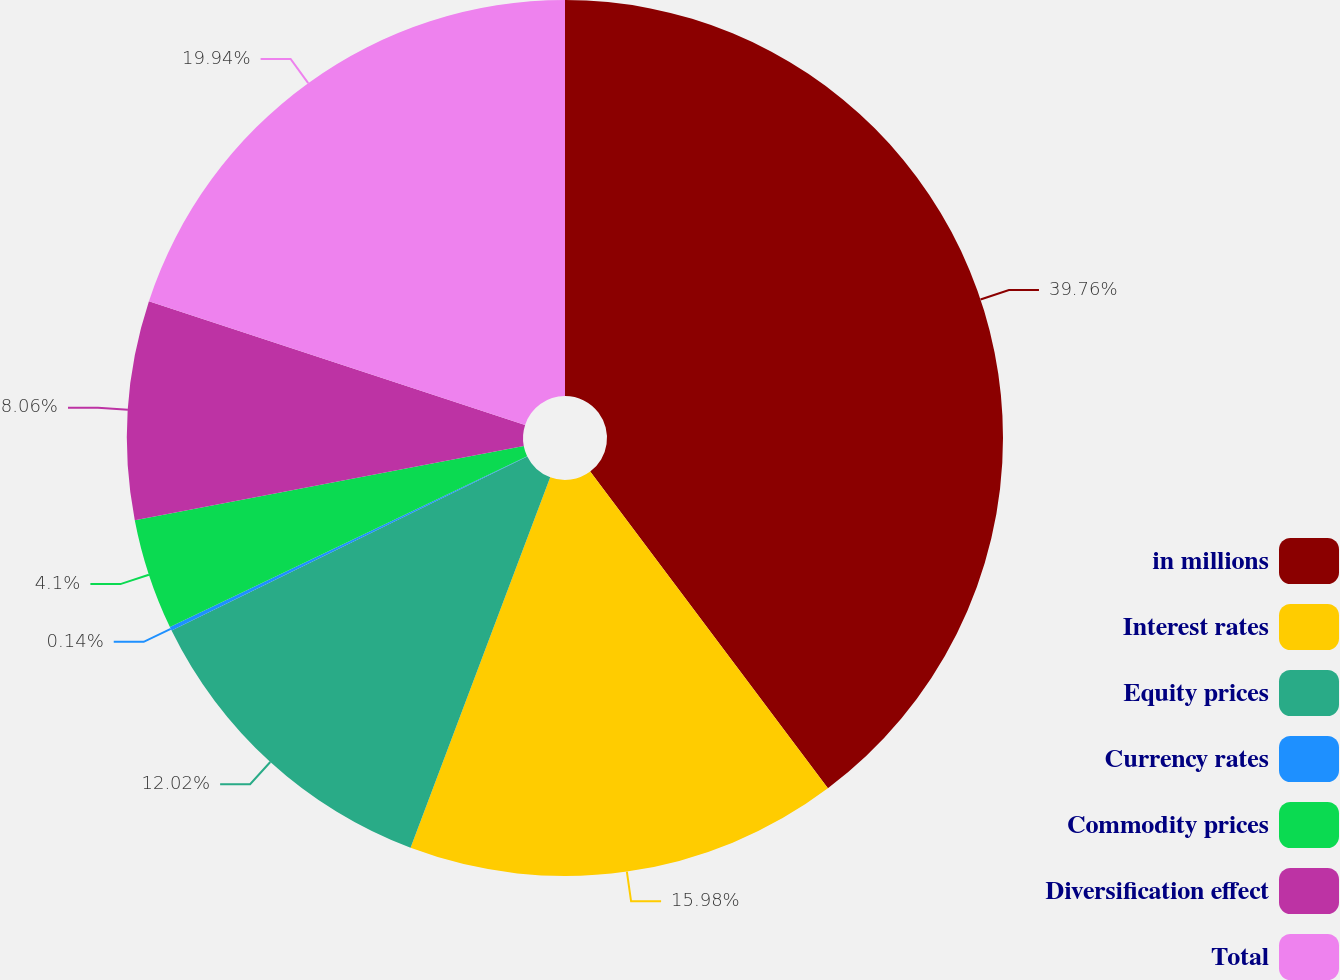Convert chart to OTSL. <chart><loc_0><loc_0><loc_500><loc_500><pie_chart><fcel>in millions<fcel>Interest rates<fcel>Equity prices<fcel>Currency rates<fcel>Commodity prices<fcel>Diversification effect<fcel>Total<nl><fcel>39.75%<fcel>15.98%<fcel>12.02%<fcel>0.14%<fcel>4.1%<fcel>8.06%<fcel>19.94%<nl></chart> 